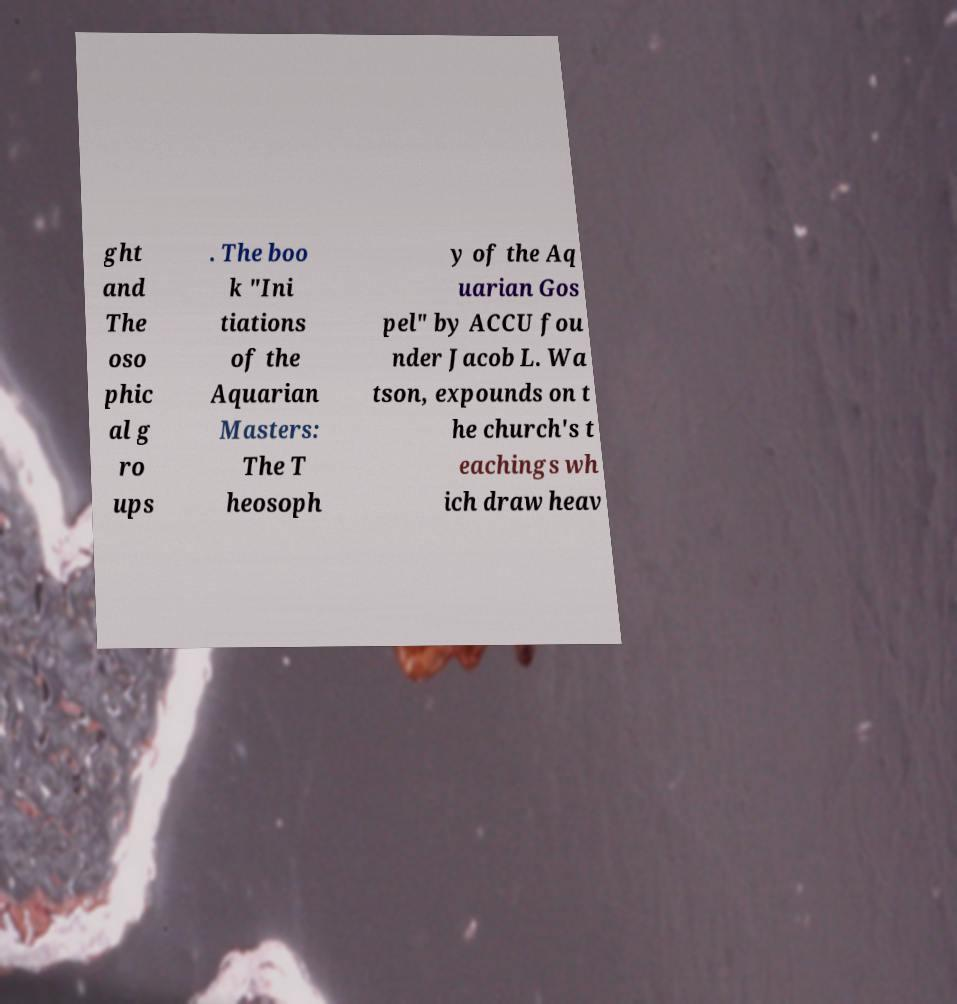I need the written content from this picture converted into text. Can you do that? ght and The oso phic al g ro ups . The boo k "Ini tiations of the Aquarian Masters: The T heosoph y of the Aq uarian Gos pel" by ACCU fou nder Jacob L. Wa tson, expounds on t he church's t eachings wh ich draw heav 